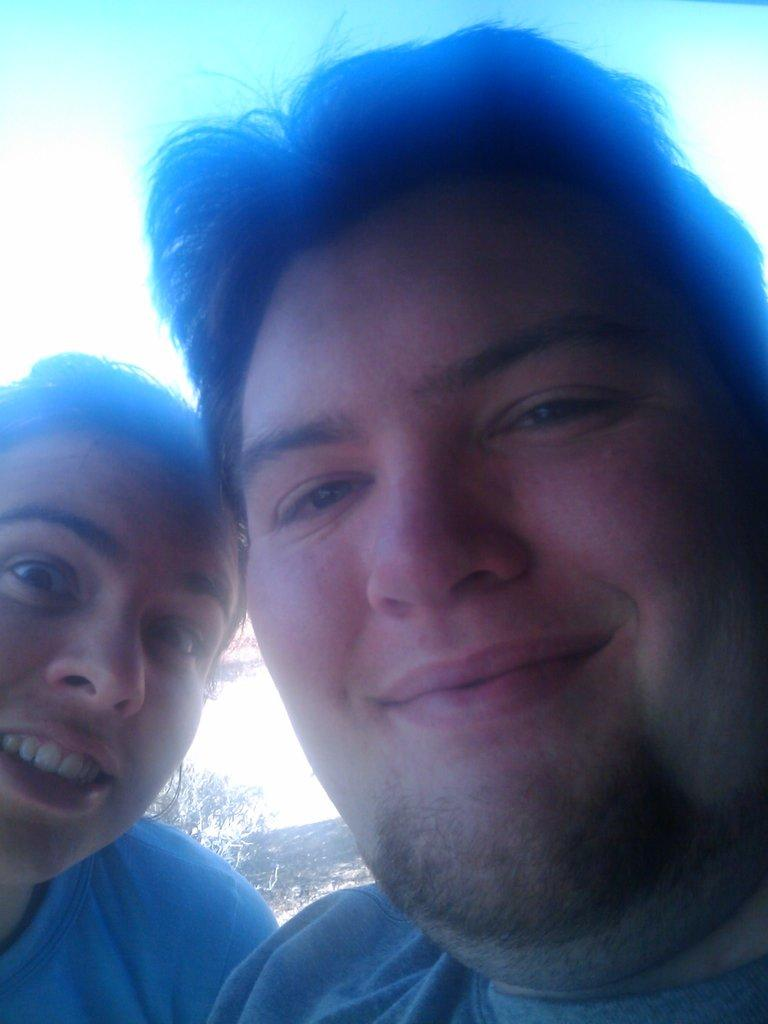How many people are present in the image? There are two people in the image. What can be seen in the background of the image? The sky is visible in the background of the image. What type of club can be seen in the image? There is no club present in the image. Is there a slope visible in the image? There is no slope visible in the image. 